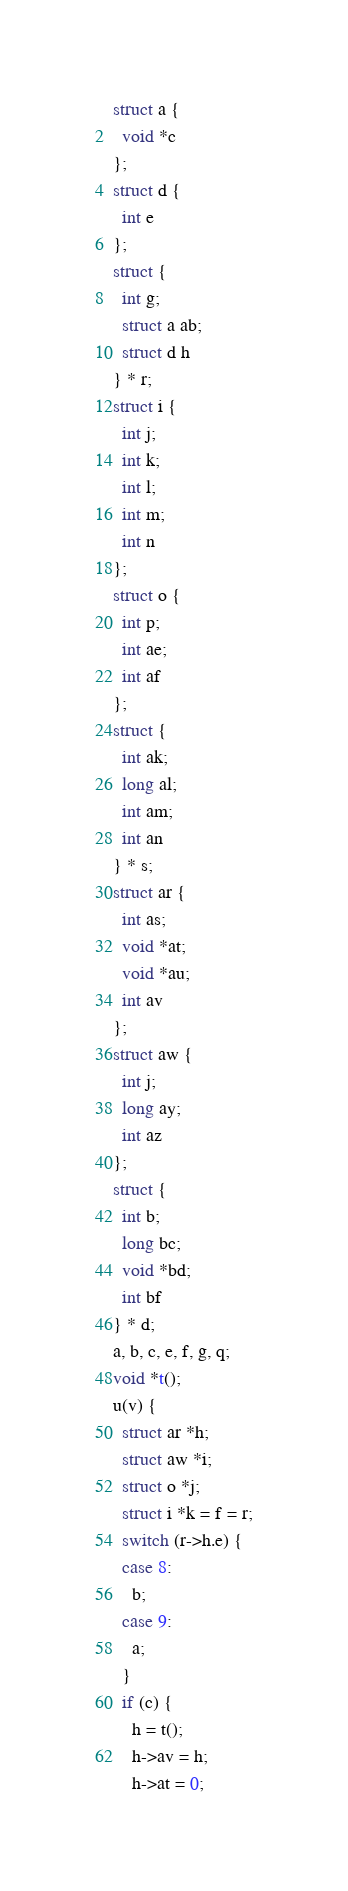Convert code to text. <code><loc_0><loc_0><loc_500><loc_500><_C_>struct a {
  void *c
};
struct d {
  int e
};
struct {
  int g;
  struct a ab;
  struct d h
} * r;
struct i {
  int j;
  int k;
  int l;
  int m;
  int n
};
struct o {
  int p;
  int ae;
  int af
};
struct {
  int ak;
  long al;
  int am;
  int an
} * s;
struct ar {
  int as;
  void *at;
  void *au;
  int av
};
struct aw {
  int j;
  long ay;
  int az
};
struct {
  int b;
  long bc;
  void *bd;
  int bf
} * d;
a, b, c, e, f, g, q;
void *t();
u(v) {
  struct ar *h;
  struct aw *i;
  struct o *j;
  struct i *k = f = r;
  switch (r->h.e) {
  case 8:
    b;
  case 9:
    a;
  }
  if (c) {
    h = t();
    h->av = h;
    h->at = 0;</code> 